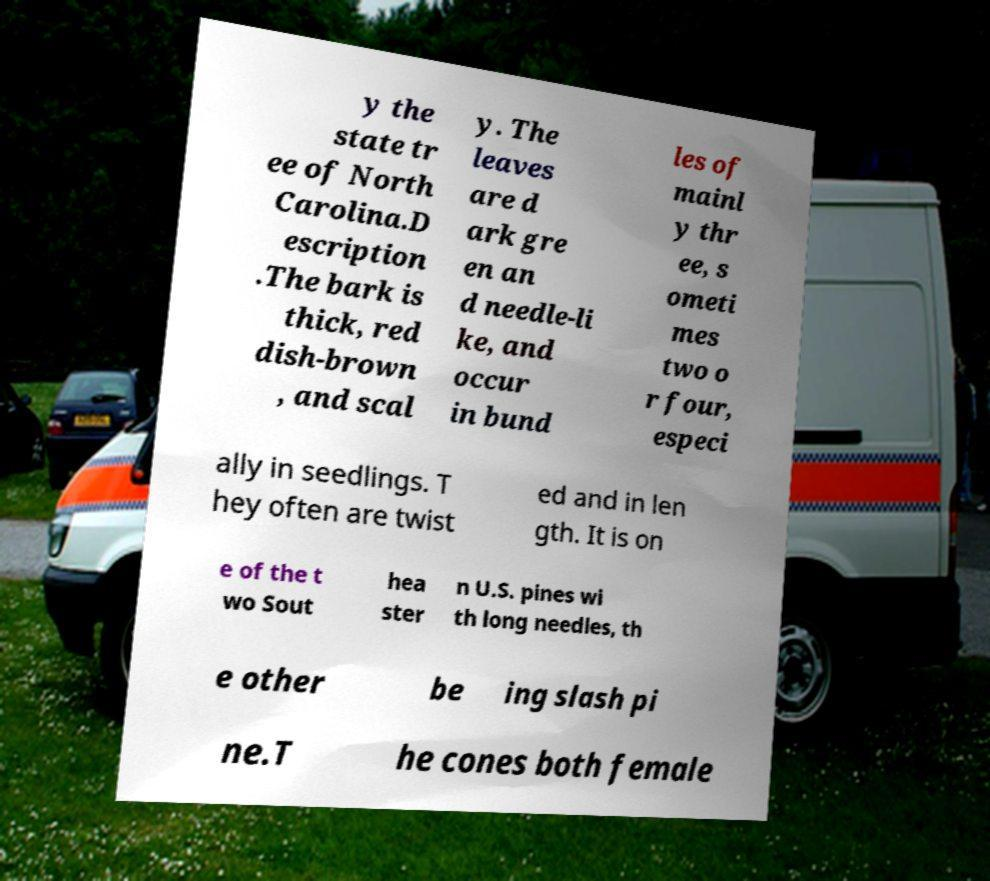There's text embedded in this image that I need extracted. Can you transcribe it verbatim? y the state tr ee of North Carolina.D escription .The bark is thick, red dish-brown , and scal y. The leaves are d ark gre en an d needle-li ke, and occur in bund les of mainl y thr ee, s ometi mes two o r four, especi ally in seedlings. T hey often are twist ed and in len gth. It is on e of the t wo Sout hea ster n U.S. pines wi th long needles, th e other be ing slash pi ne.T he cones both female 